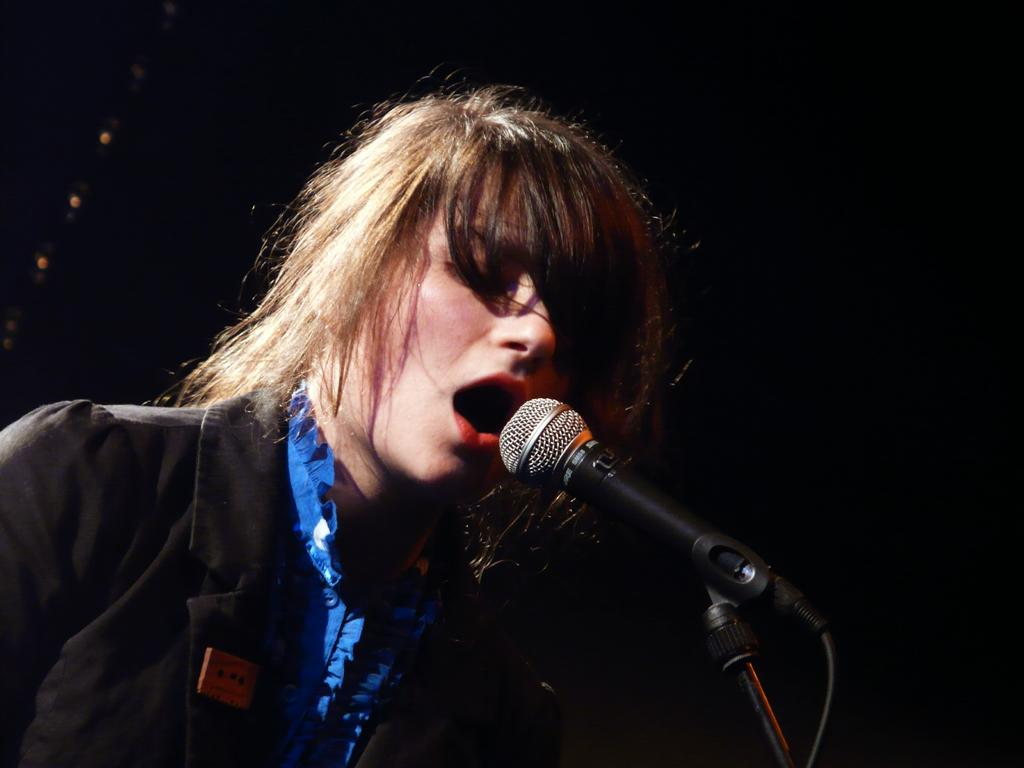Who or what is the main subject of the image? There is a person in the image. What object is in front of the person? There is a microphone in front of the person. What can be observed about the background of the image? The background of the image is dark. What is the tendency of the moon in the image? The image does not show the moon, so it is not possible to determine its tendency. 